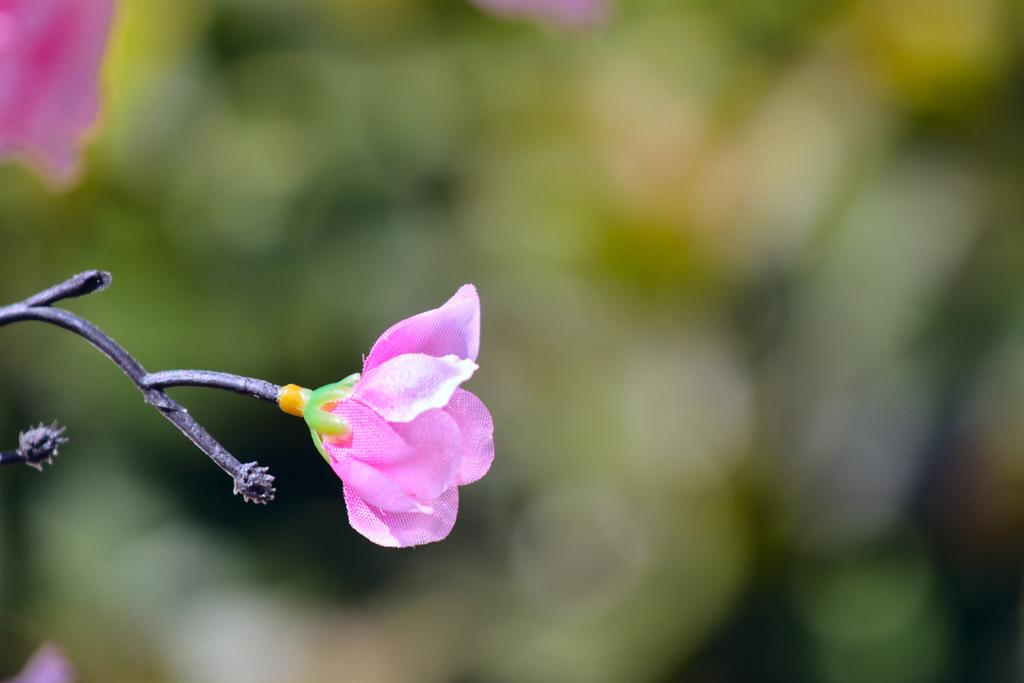What is the main subject in the foreground of the image? There is a flower in the foreground of the image. What can be seen in the background of the image? There are plants in the background of the image. What type of goose can be seen in the image? There is no goose present in the image; it only features a flower in the foreground and plants in the background. 